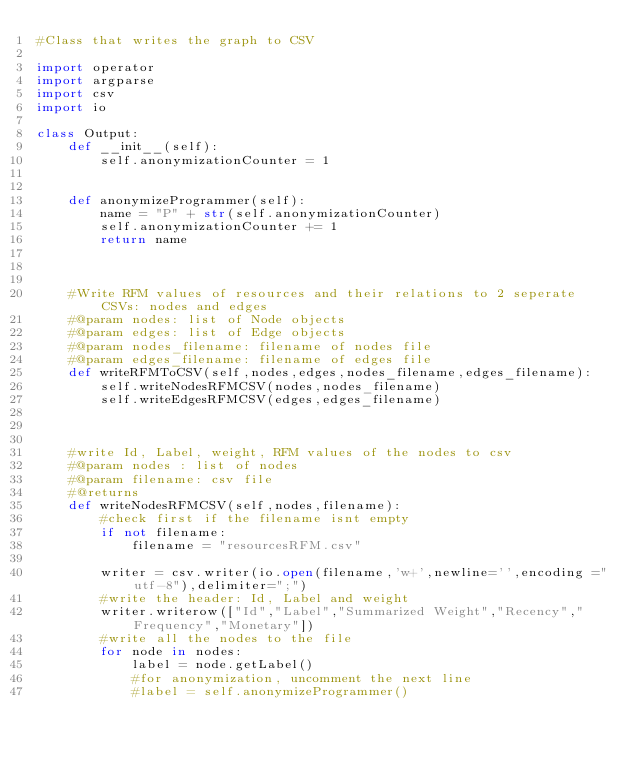<code> <loc_0><loc_0><loc_500><loc_500><_Python_>#Class that writes the graph to CSV

import operator
import argparse
import csv
import io

class Output:
    def __init__(self):
        self.anonymizationCounter = 1


    def anonymizeProgrammer(self):
        name = "P" + str(self.anonymizationCounter)
        self.anonymizationCounter += 1
        return name

    

    #Write RFM values of resources and their relations to 2 seperate CSVs: nodes and edges
    #@param nodes: list of Node objects
    #@param edges: list of Edge objects
    #@param nodes_filename: filename of nodes file
    #@param edges_filename: filename of edges file
    def writeRFMToCSV(self,nodes,edges,nodes_filename,edges_filename):
        self.writeNodesRFMCSV(nodes,nodes_filename)
        self.writeEdgesRFMCSV(edges,edges_filename)



    #write Id, Label, weight, RFM values of the nodes to csv
    #@param nodes : list of nodes
    #@param filename: csv file
    #@returns
    def writeNodesRFMCSV(self,nodes,filename):
        #check first if the filename isnt empty
        if not filename:
            filename = "resourcesRFM.csv"

        writer = csv.writer(io.open(filename,'w+',newline='',encoding ="utf-8"),delimiter=";")
        #write the header: Id, Label and weight
        writer.writerow(["Id","Label","Summarized Weight","Recency","Frequency","Monetary"])
        #write all the nodes to the file
        for node in nodes:
            label = node.getLabel()
            #for anonymization, uncomment the next line
            #label = self.anonymizeProgrammer()</code> 